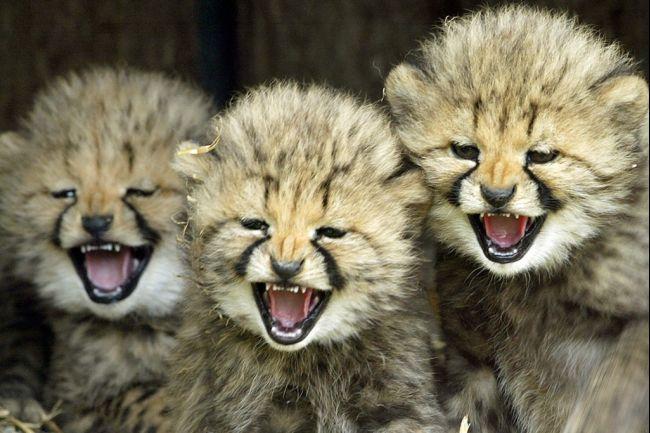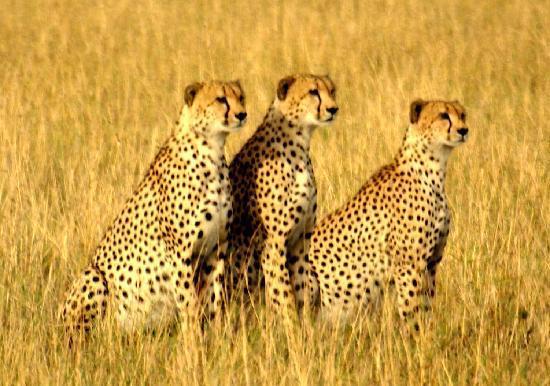The first image is the image on the left, the second image is the image on the right. For the images displayed, is the sentence "At least two animals are laying down." factually correct? Answer yes or no. No. The first image is the image on the left, the second image is the image on the right. Analyze the images presented: Is the assertion "There are three adult cheetahs in one image and three cheetah cubs in the other image." valid? Answer yes or no. Yes. 